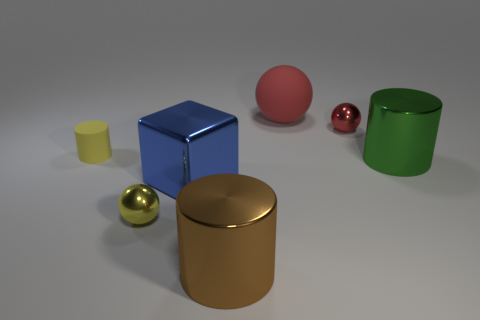Subtract all tiny shiny spheres. How many spheres are left? 1 Add 1 yellow rubber things. How many objects exist? 8 Subtract all yellow balls. How many balls are left? 2 Subtract 1 cubes. How many cubes are left? 0 Add 7 tiny spheres. How many tiny spheres are left? 9 Add 5 big cubes. How many big cubes exist? 6 Subtract 1 yellow cylinders. How many objects are left? 6 Subtract all cylinders. How many objects are left? 4 Subtract all cyan cubes. Subtract all purple balls. How many cubes are left? 1 Subtract all blue blocks. How many yellow cylinders are left? 1 